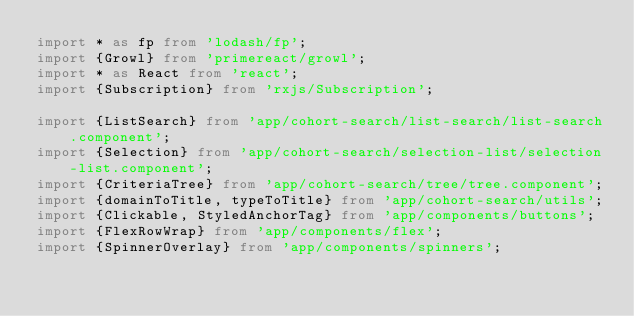Convert code to text. <code><loc_0><loc_0><loc_500><loc_500><_TypeScript_>import * as fp from 'lodash/fp';
import {Growl} from 'primereact/growl';
import * as React from 'react';
import {Subscription} from 'rxjs/Subscription';

import {ListSearch} from 'app/cohort-search/list-search/list-search.component';
import {Selection} from 'app/cohort-search/selection-list/selection-list.component';
import {CriteriaTree} from 'app/cohort-search/tree/tree.component';
import {domainToTitle, typeToTitle} from 'app/cohort-search/utils';
import {Clickable, StyledAnchorTag} from 'app/components/buttons';
import {FlexRowWrap} from 'app/components/flex';
import {SpinnerOverlay} from 'app/components/spinners';</code> 